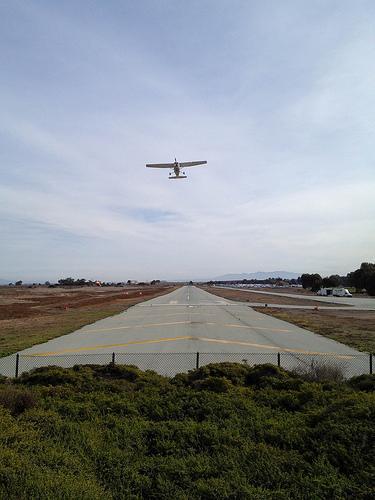How many planes?
Give a very brief answer. 1. 